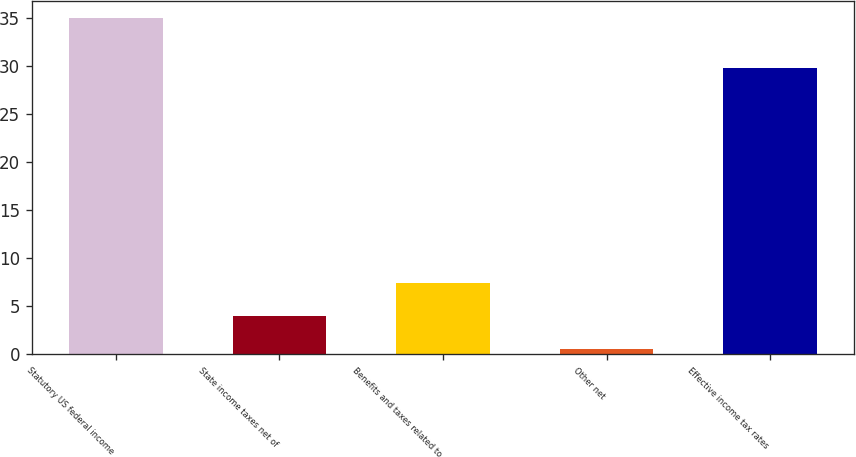Convert chart to OTSL. <chart><loc_0><loc_0><loc_500><loc_500><bar_chart><fcel>Statutory US federal income<fcel>State income taxes net of<fcel>Benefits and taxes related to<fcel>Other net<fcel>Effective income tax rates<nl><fcel>35<fcel>3.95<fcel>7.4<fcel>0.5<fcel>29.8<nl></chart> 